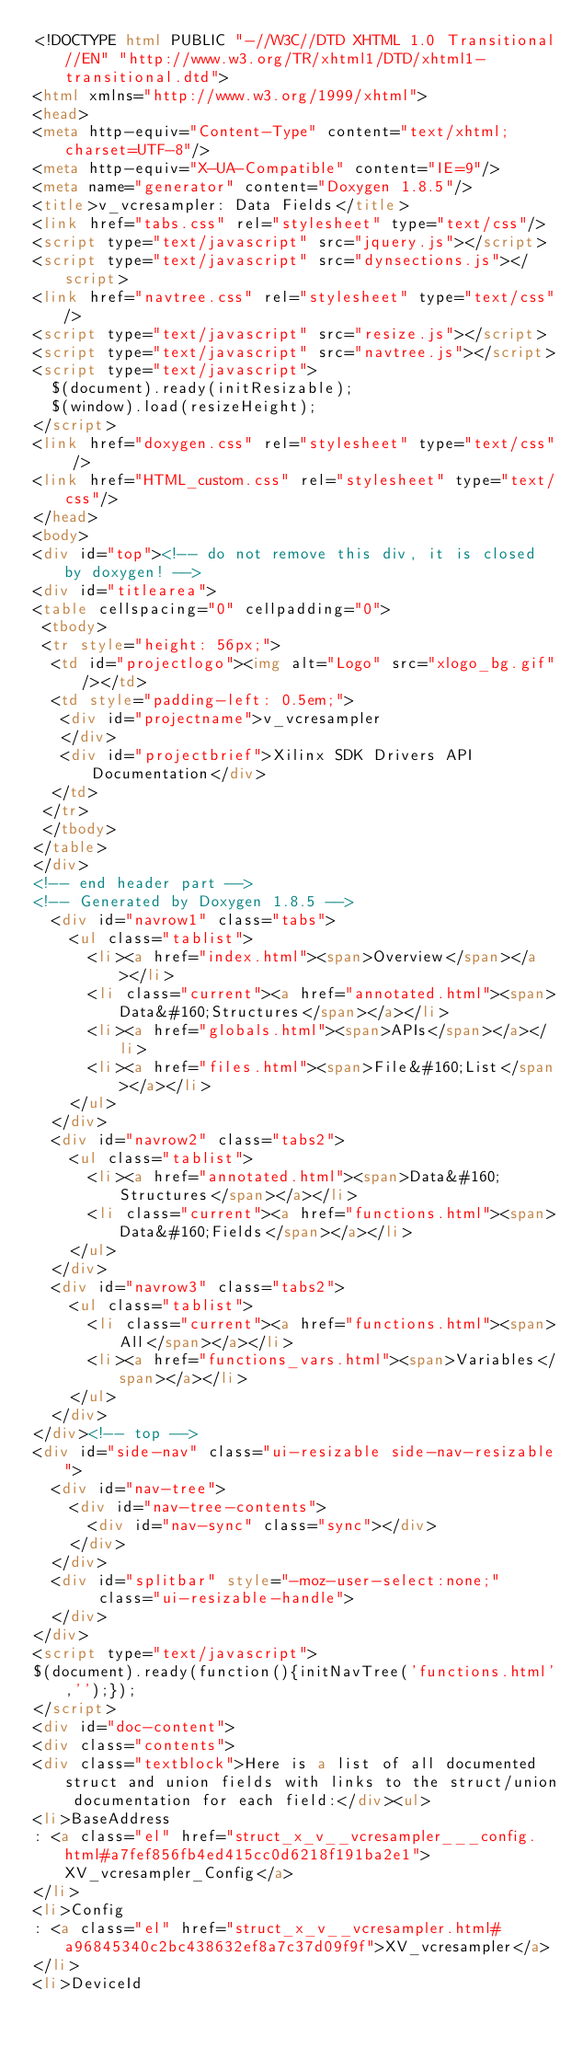Convert code to text. <code><loc_0><loc_0><loc_500><loc_500><_HTML_><!DOCTYPE html PUBLIC "-//W3C//DTD XHTML 1.0 Transitional//EN" "http://www.w3.org/TR/xhtml1/DTD/xhtml1-transitional.dtd">
<html xmlns="http://www.w3.org/1999/xhtml">
<head>
<meta http-equiv="Content-Type" content="text/xhtml;charset=UTF-8"/>
<meta http-equiv="X-UA-Compatible" content="IE=9"/>
<meta name="generator" content="Doxygen 1.8.5"/>
<title>v_vcresampler: Data Fields</title>
<link href="tabs.css" rel="stylesheet" type="text/css"/>
<script type="text/javascript" src="jquery.js"></script>
<script type="text/javascript" src="dynsections.js"></script>
<link href="navtree.css" rel="stylesheet" type="text/css"/>
<script type="text/javascript" src="resize.js"></script>
<script type="text/javascript" src="navtree.js"></script>
<script type="text/javascript">
  $(document).ready(initResizable);
  $(window).load(resizeHeight);
</script>
<link href="doxygen.css" rel="stylesheet" type="text/css" />
<link href="HTML_custom.css" rel="stylesheet" type="text/css"/>
</head>
<body>
<div id="top"><!-- do not remove this div, it is closed by doxygen! -->
<div id="titlearea">
<table cellspacing="0" cellpadding="0">
 <tbody>
 <tr style="height: 56px;">
  <td id="projectlogo"><img alt="Logo" src="xlogo_bg.gif"/></td>
  <td style="padding-left: 0.5em;">
   <div id="projectname">v_vcresampler
   </div>
   <div id="projectbrief">Xilinx SDK Drivers API Documentation</div>
  </td>
 </tr>
 </tbody>
</table>
</div>
<!-- end header part -->
<!-- Generated by Doxygen 1.8.5 -->
  <div id="navrow1" class="tabs">
    <ul class="tablist">
      <li><a href="index.html"><span>Overview</span></a></li>
      <li class="current"><a href="annotated.html"><span>Data&#160;Structures</span></a></li>
      <li><a href="globals.html"><span>APIs</span></a></li>
      <li><a href="files.html"><span>File&#160;List</span></a></li>
    </ul>
  </div>
  <div id="navrow2" class="tabs2">
    <ul class="tablist">
      <li><a href="annotated.html"><span>Data&#160;Structures</span></a></li>
      <li class="current"><a href="functions.html"><span>Data&#160;Fields</span></a></li>
    </ul>
  </div>
  <div id="navrow3" class="tabs2">
    <ul class="tablist">
      <li class="current"><a href="functions.html"><span>All</span></a></li>
      <li><a href="functions_vars.html"><span>Variables</span></a></li>
    </ul>
  </div>
</div><!-- top -->
<div id="side-nav" class="ui-resizable side-nav-resizable">
  <div id="nav-tree">
    <div id="nav-tree-contents">
      <div id="nav-sync" class="sync"></div>
    </div>
  </div>
  <div id="splitbar" style="-moz-user-select:none;" 
       class="ui-resizable-handle">
  </div>
</div>
<script type="text/javascript">
$(document).ready(function(){initNavTree('functions.html','');});
</script>
<div id="doc-content">
<div class="contents">
<div class="textblock">Here is a list of all documented struct and union fields with links to the struct/union documentation for each field:</div><ul>
<li>BaseAddress
: <a class="el" href="struct_x_v__vcresampler___config.html#a7fef856fb4ed415cc0d6218f191ba2e1">XV_vcresampler_Config</a>
</li>
<li>Config
: <a class="el" href="struct_x_v__vcresampler.html#a96845340c2bc438632ef8a7c37d09f9f">XV_vcresampler</a>
</li>
<li>DeviceId</code> 